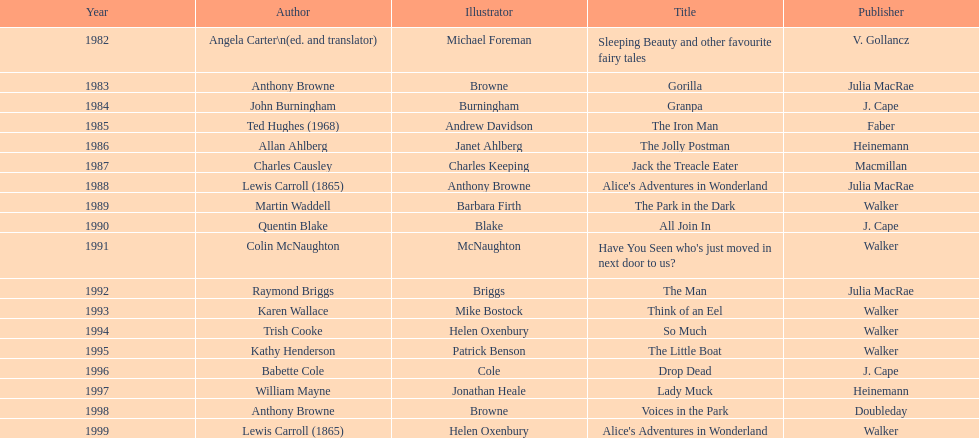How many total titles were published by walker? 5. 